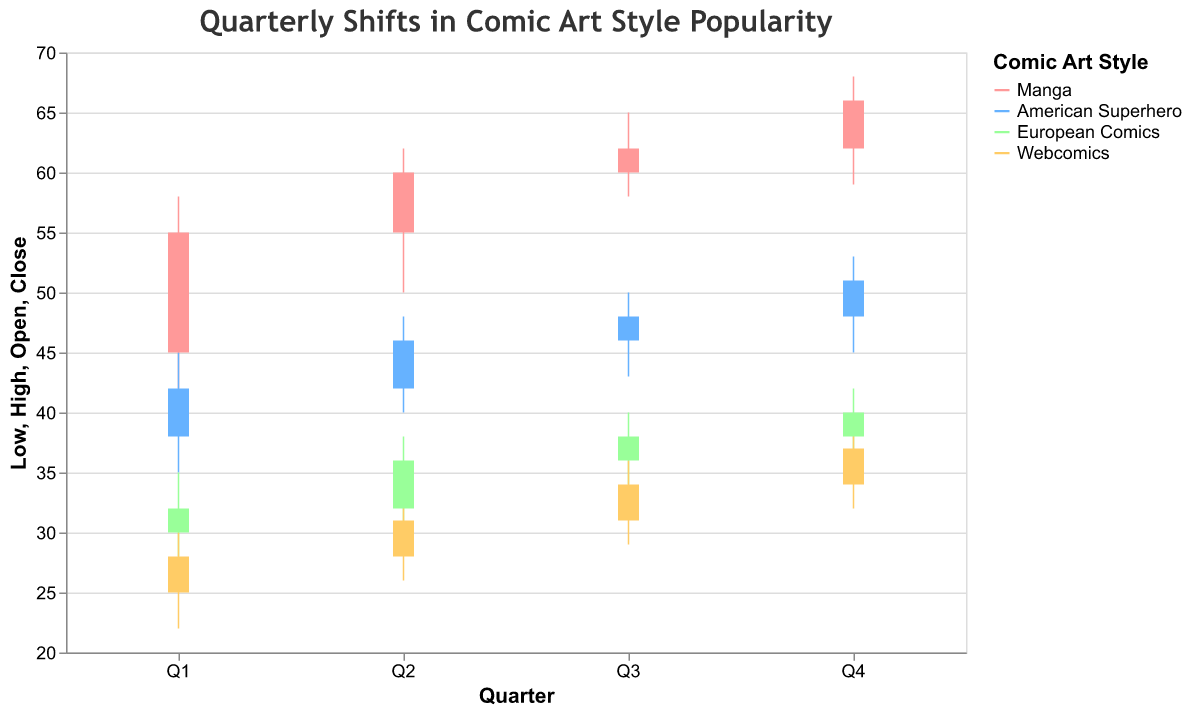What's the title of the figure? The title is typically located at the top of the figure and succinctly describes its content. Here, the title reads "Quarterly Shifts in Comic Art Style Popularity".
Answer: Quarterly Shifts in Comic Art Style Popularity Which comic art style had the highest closing value in Q4? By examining the OHLC bars labeled "Q4", we can see that the Manga style has the highest closing value, marked 66.
Answer: Manga What is the range (difference between high and low) of the American Superhero style in Q2? Look at the Q2 data for American Superhero. The high value is 48 and the low value is 40. Subtracting the low from the high gives 48 - 40 = 8.
Answer: 8 Which comic art style had consistent increases in closing values every quarter? Reviewing the closing values for each quarter: Manga (55, 60, 62, 66), American Superhero (42, 46, 48, 51), European Comics (32, 36, 38, 40), Webcomics (28, 31, 34, 37). Manga, American Superhero, European Comics, and Webcomics all show consistent quarterly increases.
Answer: Manga, American Superhero, European Comics, Webcomics Between which quarters did the European Comics style see the largest increase in its closing value? Compare the quarter-to-quarter increments in the European Comics data: Q1 to Q2 (32 to 36 = 4), Q2 to Q3 (36 to 38 = 2), Q3 to Q4 (38 to 40 = 2). The largest increase is from Q1 to Q2, which is a change of 4.
Answer: Q1 to Q2 Which style saw the highest value overall in the dataset? By scanning the entire dataset, the highest value is the "High" value for manga in Q4, which is 68.
Answer: Manga Did any comic art style have a quarter where the closing value decreased from the previous quarter? Reviewing the closing values across all quarters: Manga (55, 60, 62, 66), American Superhero (42, 46, 48, 51), European Comics (32, 36, 38, 40), Webcomics (28, 31, 34, 37). None of the styles had a quarter where the closing value decreased.
Answer: No What was the open value for Webcomics in Q3? Locate the Q3 data for Webcomics, where the open value is shown as 31.
Answer: 31 What's the average closing value for Manga across all quarters? Sum the closing values for Manga (55 + 60 + 62 + 66 = 243) and divide by the number of quarters (4). The average is 243 / 4 = 60.75.
Answer: 60.75 In which quarter did American Superhero reach its highest close value? Examine the closing values for American Superhero across all quarters: Q1 (42), Q2 (46), Q3 (48), Q4 (51). Q4 has the highest close value of 51.
Answer: Q4 